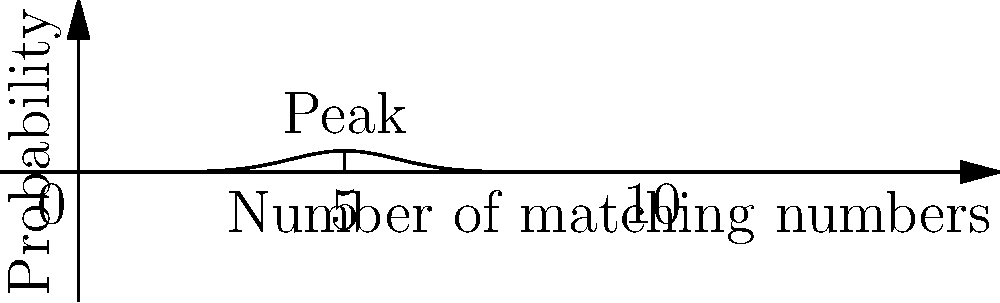As a lottery ticket vendor, you're explaining to a customer the probability distribution of matching numbers in a lottery. The curve shown represents the probability distribution for a 10-number lottery. If the probability of matching 5 numbers is at the peak of the curve, what is the probability of matching exactly 7 numbers, given that the area under the entire curve is 1? To solve this problem, we'll use the properties of the normal distribution:

1. Recognize that this is a normal distribution curve centered at 5.
2. The standard deviation can be estimated as 1/3 of the distance from the mean to the edge of the data (approximately 1.67).
3. To find the probability of matching exactly 7 numbers, we need to calculate the z-score:

   $$z = \frac{x - \mu}{\sigma} = \frac{7 - 5}{1.67} \approx 1.20$$

4. Using a standard normal distribution table or calculator, find the height of the curve at z = 1.20:

   $$f(z) \approx 0.1942$$

5. To convert this to the actual probability, we need to multiply by the width of each "slot" (1 in this case):

   $$P(X = 7) \approx 0.1942 \times 1 = 0.1942$$

6. This can be interpreted as approximately a 19.42% chance of matching exactly 7 numbers.
Answer: $0.1942$ or $19.42\%$ 